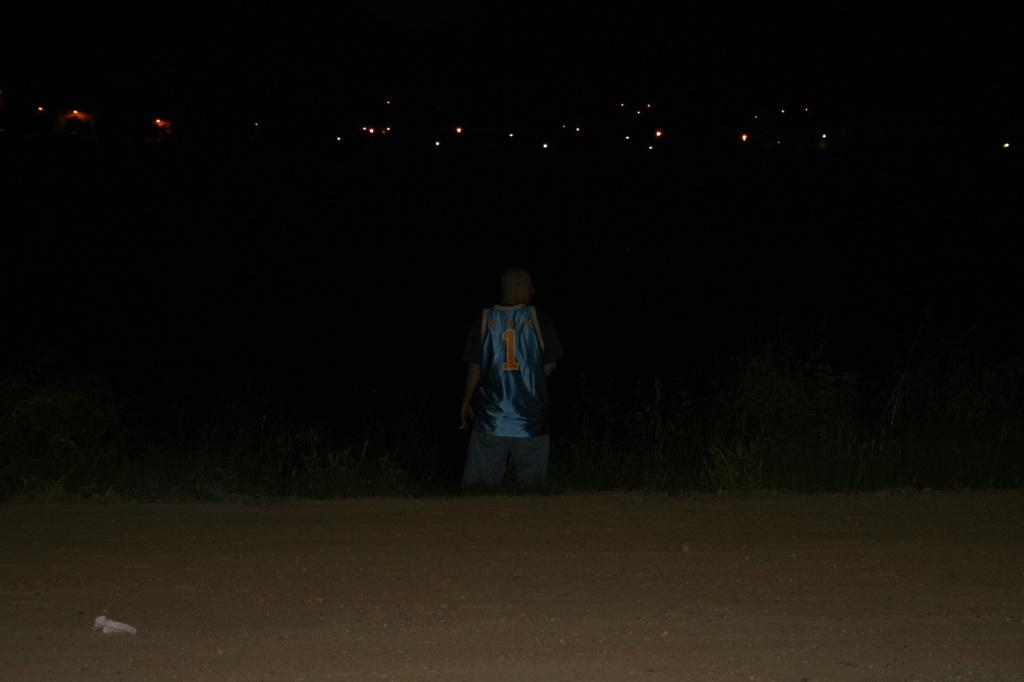What is the main subject of the image? There is a person in the image. What type of surface is visible beneath the person? There is grass in the image. What else can be seen in the image besides the person and grass? There are other objects in the image. What can be seen in the background of the image? There are lights visible in the background of the image. What color is the background of the image? The background of the image is black. What is visible at the bottom of the image? The ground is visible at the bottom of the image. What type of cheese is being used as a unit of measurement in the image? There is no cheese or unit of measurement present in the image. What type of root is growing out of the person's head in the image? There is no root growing out of the person's head in the image. 